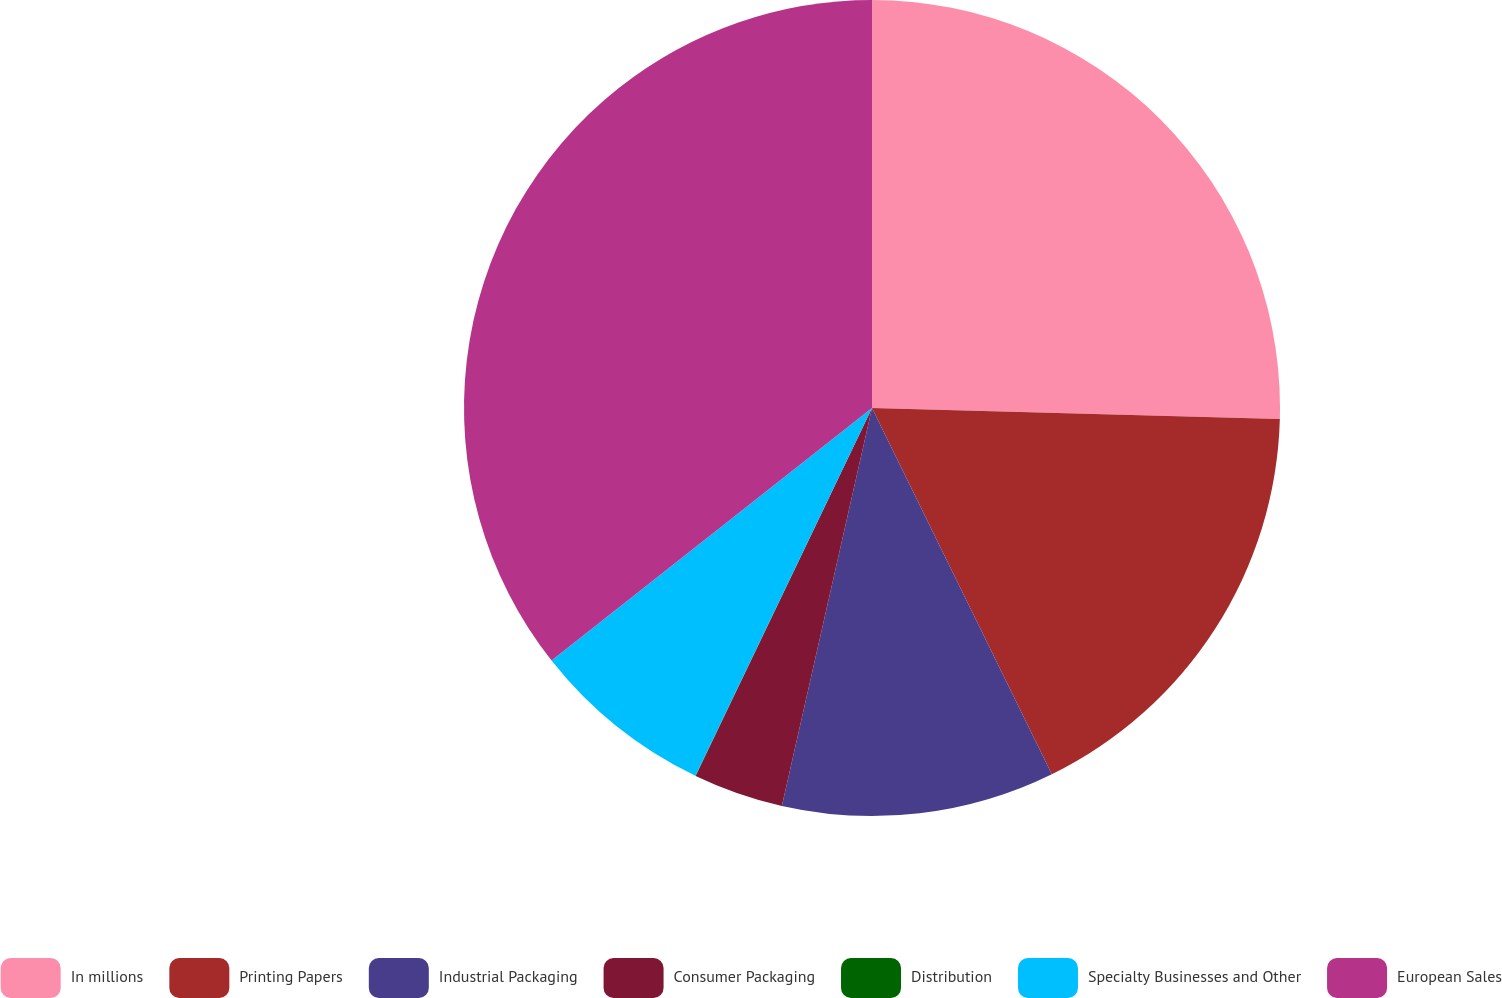Convert chart to OTSL. <chart><loc_0><loc_0><loc_500><loc_500><pie_chart><fcel>In millions<fcel>Printing Papers<fcel>Industrial Packaging<fcel>Consumer Packaging<fcel>Distribution<fcel>Specialty Businesses and Other<fcel>European Sales<nl><fcel>25.43%<fcel>17.3%<fcel>10.81%<fcel>3.57%<fcel>0.01%<fcel>7.25%<fcel>35.62%<nl></chart> 